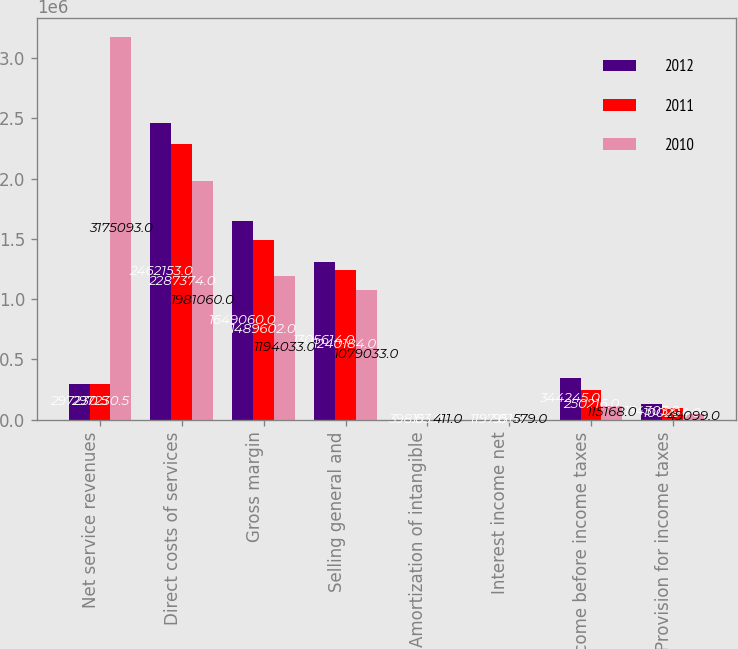Convert chart. <chart><loc_0><loc_0><loc_500><loc_500><stacked_bar_chart><ecel><fcel>Net service revenues<fcel>Direct costs of services<fcel>Gross margin<fcel>Selling general and<fcel>Amortization of intangible<fcel>Interest income net<fcel>Income before income taxes<fcel>Provision for income taxes<nl><fcel>2012<fcel>297230<fcel>2.46215e+06<fcel>1.64906e+06<fcel>1.30561e+06<fcel>398<fcel>1197<fcel>344245<fcel>134303<nl><fcel>2011<fcel>297230<fcel>2.28737e+06<fcel>1.4896e+06<fcel>1.24018e+06<fcel>153<fcel>951<fcel>250216<fcel>100294<nl><fcel>2010<fcel>3.17509e+06<fcel>1.98106e+06<fcel>1.19403e+06<fcel>1.07903e+06<fcel>411<fcel>579<fcel>115168<fcel>49099<nl></chart> 